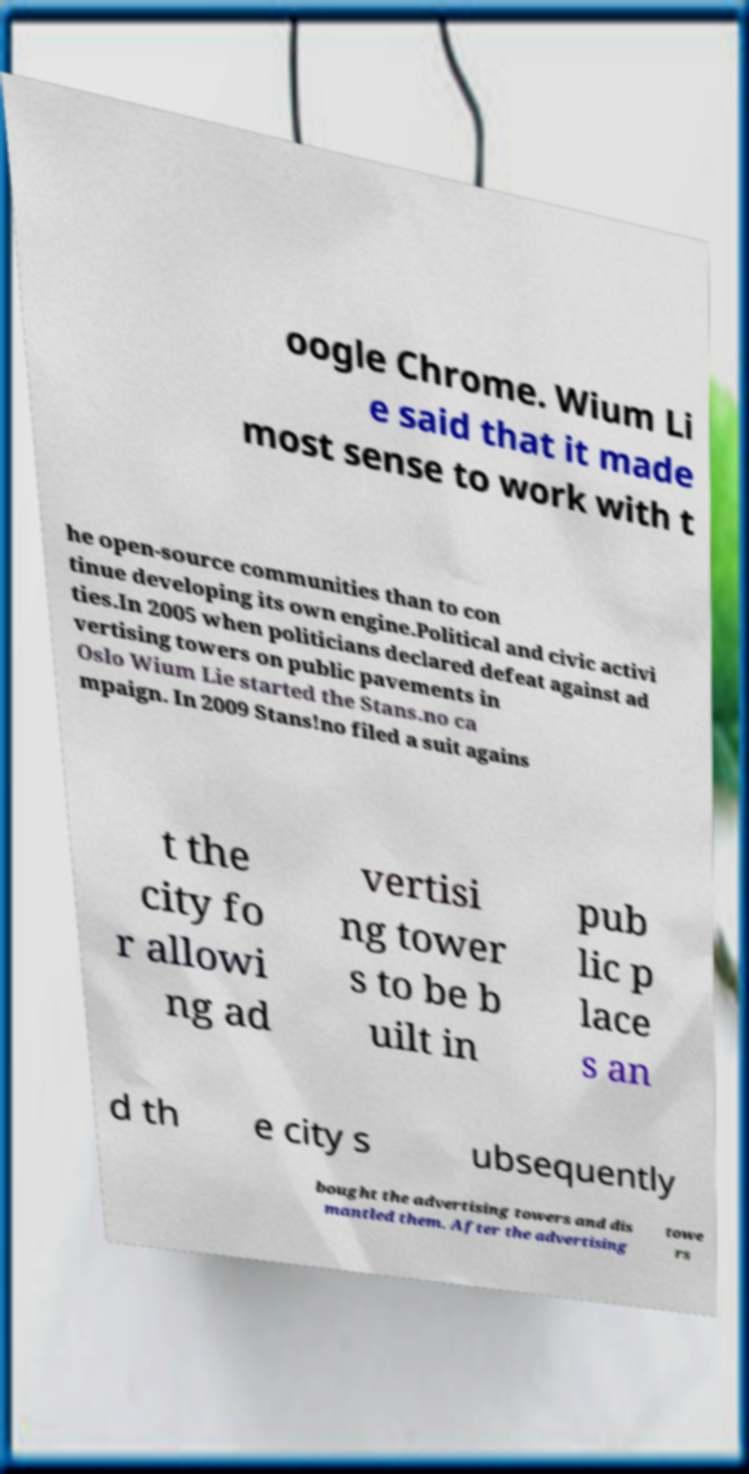Could you assist in decoding the text presented in this image and type it out clearly? oogle Chrome. Wium Li e said that it made most sense to work with t he open-source communities than to con tinue developing its own engine.Political and civic activi ties.In 2005 when politicians declared defeat against ad vertising towers on public pavements in Oslo Wium Lie started the Stans.no ca mpaign. In 2009 Stans!no filed a suit agains t the city fo r allowi ng ad vertisi ng tower s to be b uilt in pub lic p lace s an d th e city s ubsequently bought the advertising towers and dis mantled them. After the advertising towe rs 